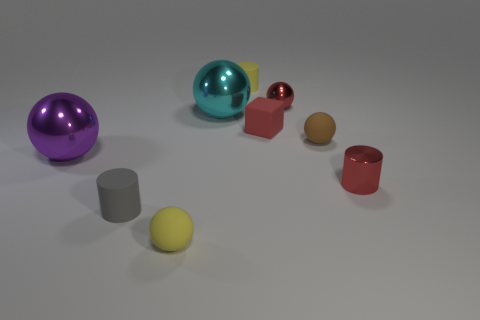Subtract all small rubber cylinders. How many cylinders are left? 1 Subtract all yellow spheres. How many spheres are left? 4 Add 1 tiny blue metal objects. How many objects exist? 10 Subtract 1 balls. How many balls are left? 4 Subtract all spheres. How many objects are left? 4 Subtract all gray cylinders. Subtract all gray blocks. How many cylinders are left? 2 Subtract all green cylinders. How many purple cubes are left? 0 Subtract all gray matte cylinders. Subtract all large red cylinders. How many objects are left? 8 Add 7 yellow rubber things. How many yellow rubber things are left? 9 Add 8 large gray objects. How many large gray objects exist? 8 